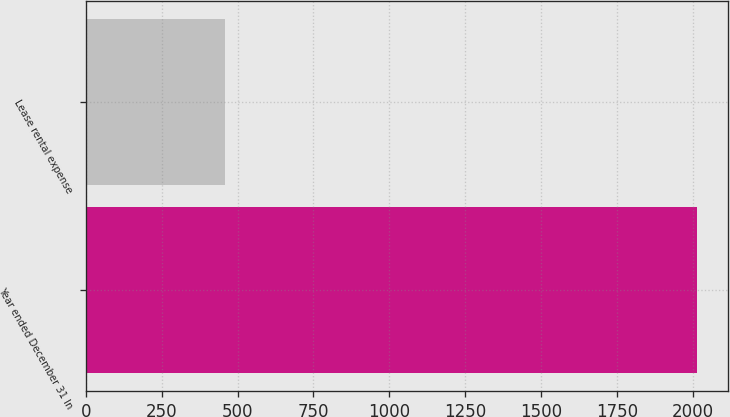Convert chart. <chart><loc_0><loc_0><loc_500><loc_500><bar_chart><fcel>Year ended December 31 In<fcel>Lease rental expense<nl><fcel>2015<fcel>460<nl></chart> 